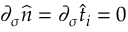<formula> <loc_0><loc_0><loc_500><loc_500>\partial _ { \sigma } \widehat { n } = \partial _ { \sigma } \widehat { t } _ { i } = 0</formula> 